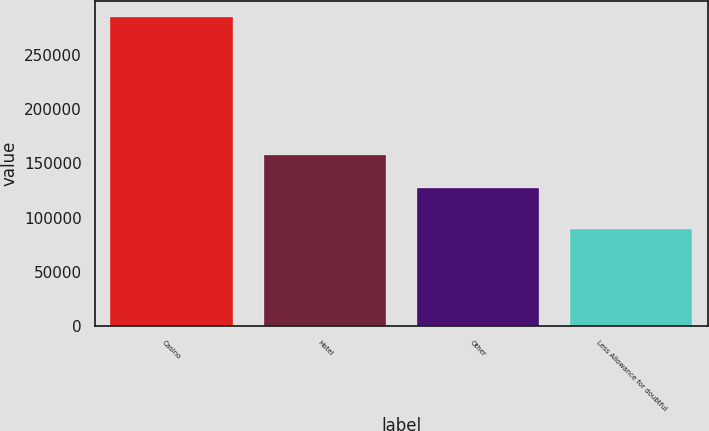Convert chart to OTSL. <chart><loc_0><loc_0><loc_500><loc_500><bar_chart><fcel>Casino<fcel>Hotel<fcel>Other<fcel>Less Allowance for doubtful<nl><fcel>285182<fcel>157489<fcel>127677<fcel>89789<nl></chart> 